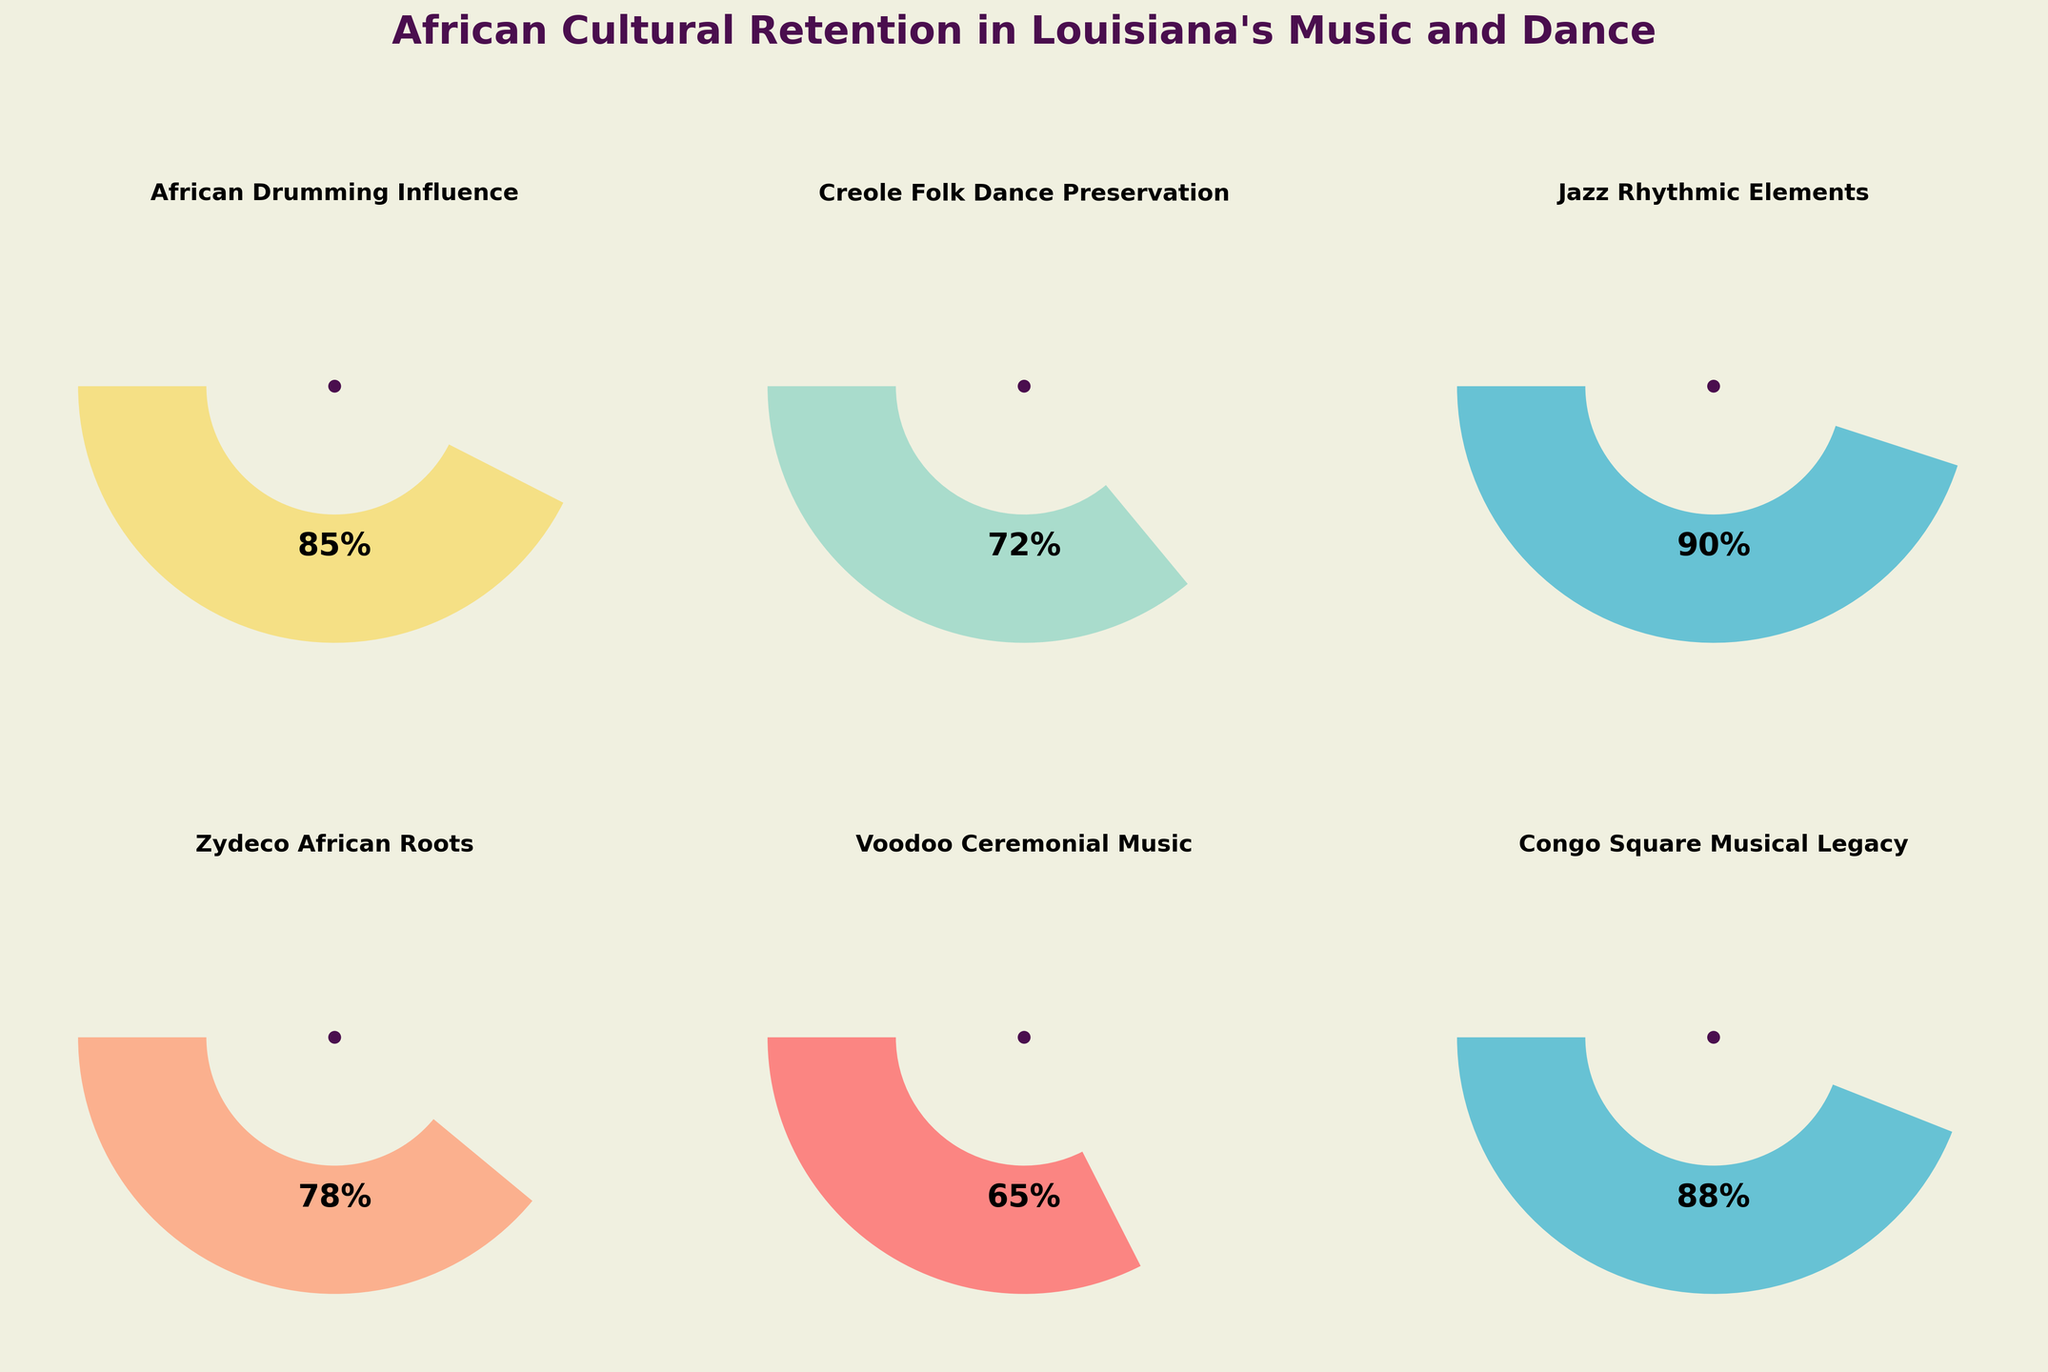How many cultural aspects are represented in the gauge charts? By counting the number of distinct titles in the gauge charts, we can determine the number of cultural aspects represented.
Answer: 6 Which cultural aspect has the highest value of African cultural retention? By examining the values displayed in each gauge chart, the one with the highest percentage represents the highest value of African cultural retention.
Answer: Jazz Rhythmic Elements Which cultural aspect shows the least African cultural retention? By examining the values displayed in each gauge chart, the one with the lowest percentage represents the least African cultural retention.
Answer: Voodoo Ceremonial Music What is the combined influence value of Creole Folk Dance and Zydeco African Roots? Adding the values of Creole Folk Dance (72) and Zydeco African Roots (78) gives the total influence value.
Answer: 150 Is the African Drumming Influence greater than Creole Folk Dance Preservation? Comparing the values, African Drumming Influence is 85, and Creole Folk Dance Preservation is 72, so 85 is greater than 72.
Answer: Yes What is the difference in value between Congo Square Musical Legacy and Voodoo Ceremonial Music? Subtract the value of Voodoo Ceremonial Music (65) from Congo Square Musical Legacy (88) to get the difference.
Answer: 23 Which three aspects have values above 80? By checking each gauge chart, African Drumming Influence (85), Jazz Rhythmic Elements (90), and Congo Square Musical Legacy (88) all have values above 80.
Answer: African Drumming Influence, Jazz Rhythmic Elements, Congo Square Musical Legacy What is the average value of cultural retention across all six aspects? Add all the values (85 + 72 + 90 + 78 + 65 + 88) and divide by 6 to find the average.
Answer: 79.67 What is the range of values across all aspects? Subtract the minimum value (65) from the maximum value (90) to find the range.
Answer: 25 